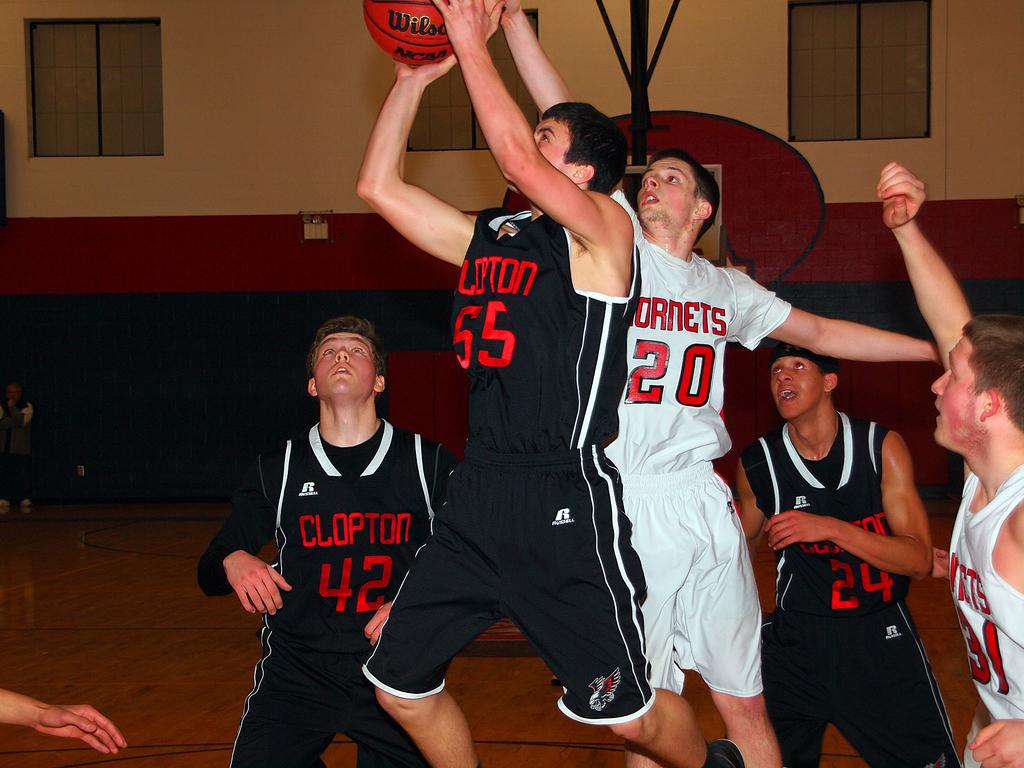<image>
Give a short and clear explanation of the subsequent image. Men playing basketball whilst wearing Clopton shirts in black 